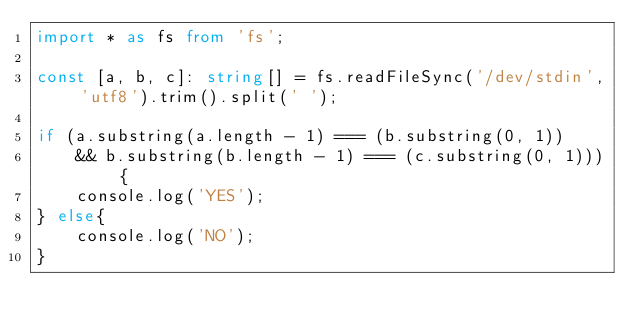<code> <loc_0><loc_0><loc_500><loc_500><_TypeScript_>import * as fs from 'fs';

const [a, b, c]: string[] = fs.readFileSync('/dev/stdin', 'utf8').trim().split(' ');

if (a.substring(a.length - 1) === (b.substring(0, 1))
    && b.substring(b.length - 1) === (c.substring(0, 1))) {
    console.log('YES');
} else{
    console.log('NO');
}</code> 